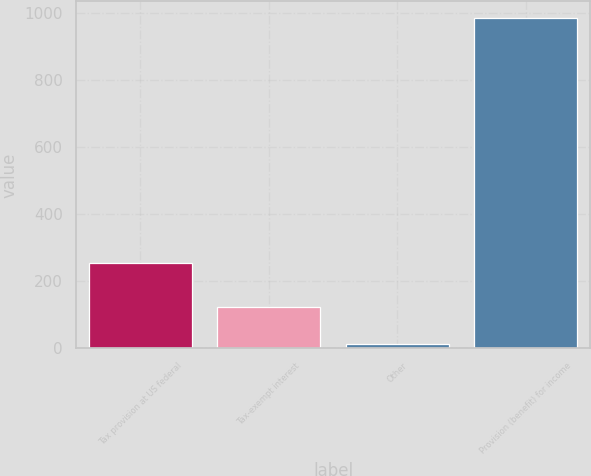Convert chart. <chart><loc_0><loc_0><loc_500><loc_500><bar_chart><fcel>Tax provision at US federal<fcel>Tax-exempt interest<fcel>Other<fcel>Provision (benefit) for income<nl><fcel>253<fcel>123<fcel>12<fcel>985<nl></chart> 